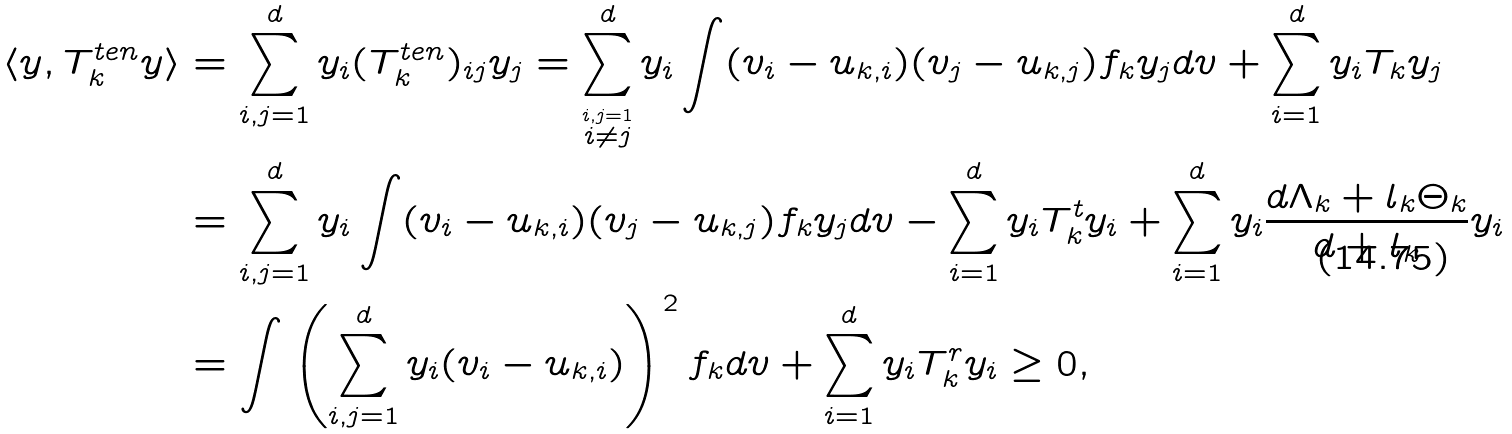<formula> <loc_0><loc_0><loc_500><loc_500>\langle y , T _ { k } ^ { t e n } y \rangle & = \sum _ { i , j = 1 } ^ { d } y _ { i } ( T _ { k } ^ { t e n } ) _ { i j } y _ { j } = \sum _ { \stackrel { i , j = 1 } { i \neq j } } ^ { d } y _ { i } \int ( v _ { i } - u _ { k , i } ) ( v _ { j } - u _ { k , j } ) f _ { k } y _ { j } d v + \sum _ { i = 1 } ^ { d } y _ { i } T _ { k } y _ { j } \\ & = \sum _ { i , j = 1 } ^ { d } y _ { i } \int ( v _ { i } - u _ { k , i } ) ( v _ { j } - u _ { k , j } ) f _ { k } y _ { j } d v - \sum _ { i = 1 } ^ { d } y _ { i } T _ { k } ^ { t } y _ { i } + \sum _ { i = 1 } ^ { d } y _ { i } \frac { d \Lambda _ { k } + l _ { k } \Theta _ { k } } { d + l _ { k } } y _ { i } \\ & = \int \left ( \sum _ { i , j = 1 } ^ { d } y _ { i } ( v _ { i } - u _ { k , i } ) \right ) ^ { 2 } f _ { k } d v + \sum _ { i = 1 } ^ { d } y _ { i } T _ { k } ^ { r } y _ { i } \geq 0 ,</formula> 